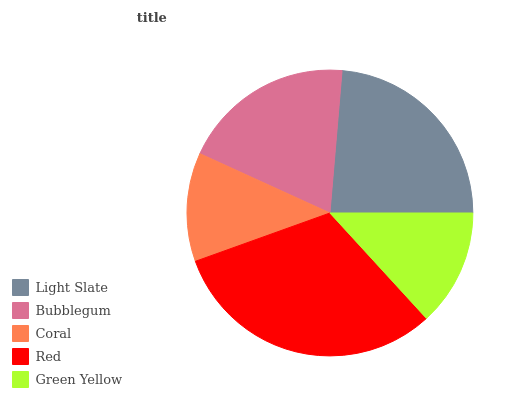Is Coral the minimum?
Answer yes or no. Yes. Is Red the maximum?
Answer yes or no. Yes. Is Bubblegum the minimum?
Answer yes or no. No. Is Bubblegum the maximum?
Answer yes or no. No. Is Light Slate greater than Bubblegum?
Answer yes or no. Yes. Is Bubblegum less than Light Slate?
Answer yes or no. Yes. Is Bubblegum greater than Light Slate?
Answer yes or no. No. Is Light Slate less than Bubblegum?
Answer yes or no. No. Is Bubblegum the high median?
Answer yes or no. Yes. Is Bubblegum the low median?
Answer yes or no. Yes. Is Coral the high median?
Answer yes or no. No. Is Green Yellow the low median?
Answer yes or no. No. 